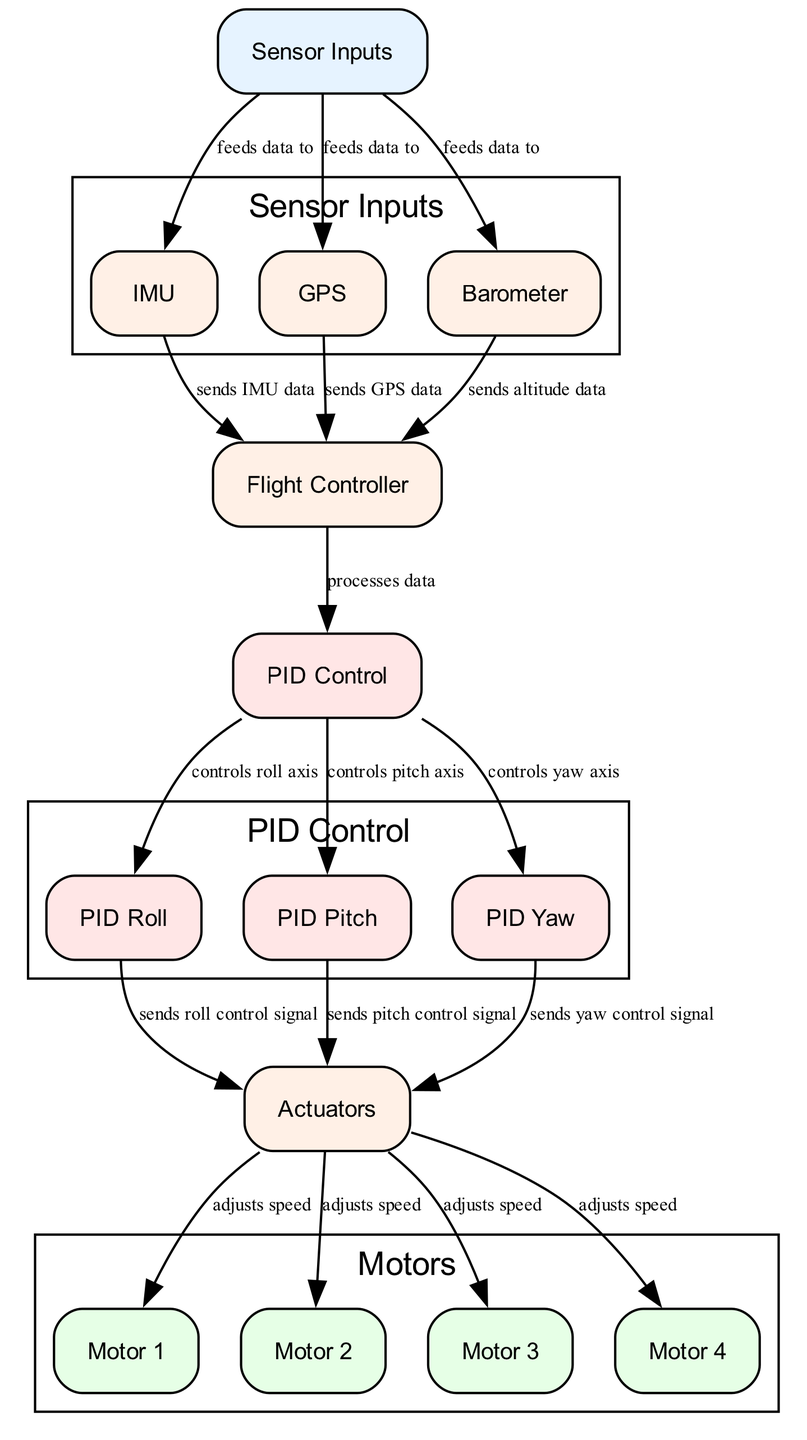What are the three types of sensor inputs depicted in the diagram? The diagram specifically lists three sensors under the "Sensor Inputs" section, which are the Inertial Measurement Unit (IMU), GPS, and Barometer.
Answer: IMU, GPS, Barometer How many motors are represented in the diagram? The diagram includes four distinct motors labeled as Motor 1, Motor 2, Motor 3, and Motor 4, indicating that there are four motors involved in the UAV system.
Answer: Four Which node directly sends data to the flight controller? The IMU, GPS, and Barometer are the nodes that send their respective data directly to the flight controller as indicated by the arrows in the diagram.
Answer: IMU, GPS, Barometer What type of control does the PID Control node provide to the roll, pitch, and yaw axes? The PID Control node processes the data it receives and then controls the roll, pitch, and yaw axes by sending appropriate control signals to their corresponding PID nodes (PID Roll, PID Pitch, PID Yaw).
Answer: Control signals How does the data flow from the actuators to the motors? The actuators send control signals which adjust the speeds of each motor. This flow is shown by arrows going from the actuators to each motor in the diagram, indicating a direct relationship.
Answer: Adjusts speed Which node is responsible for processing data from sensors? The Flight Controller node is the central unit that processes all the incoming sensor data and subsequently calculates the necessary control signals for the UAV's flight.
Answer: Flight Controller What is the function of the Barometer in the diagram? The Barometer is responsible for measuring altitude based on atmospheric pressure and sends this altitude data to the Flight Controller.
Answer: Measures altitude How does PID Control maintain stable flight? The PID Control node uses feedback from the roll, pitch, and yaw control nodes to adjust the UAV's orientation and maintain stable flight by managing the response to changes in the specified axes.
Answer: Maintains stable flight 